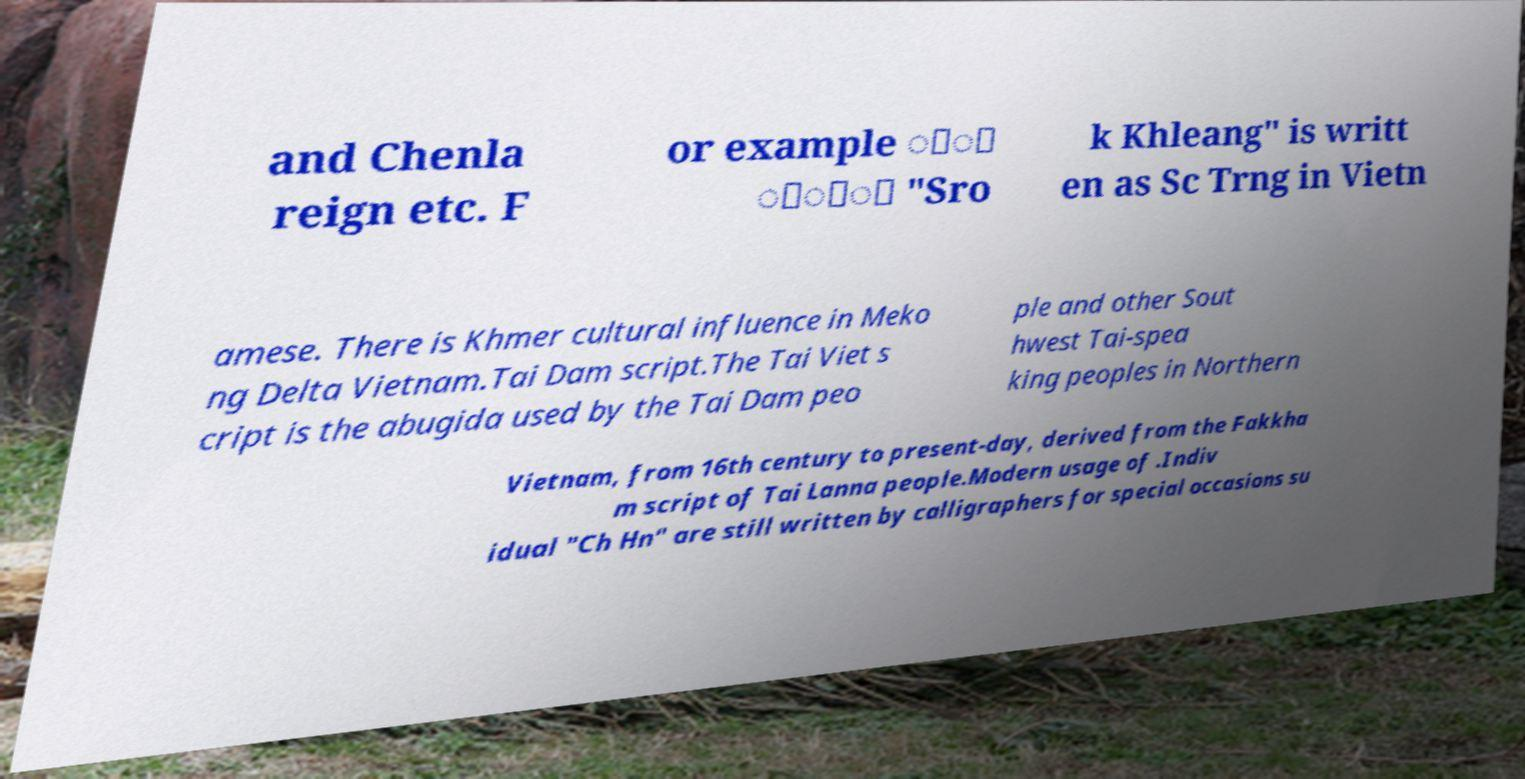What messages or text are displayed in this image? I need them in a readable, typed format. and Chenla reign etc. F or example ្ុ ្ាំ "Sro k Khleang" is writt en as Sc Trng in Vietn amese. There is Khmer cultural influence in Meko ng Delta Vietnam.Tai Dam script.The Tai Viet s cript is the abugida used by the Tai Dam peo ple and other Sout hwest Tai-spea king peoples in Northern Vietnam, from 16th century to present-day, derived from the Fakkha m script of Tai Lanna people.Modern usage of .Indiv idual "Ch Hn" are still written by calligraphers for special occasions su 